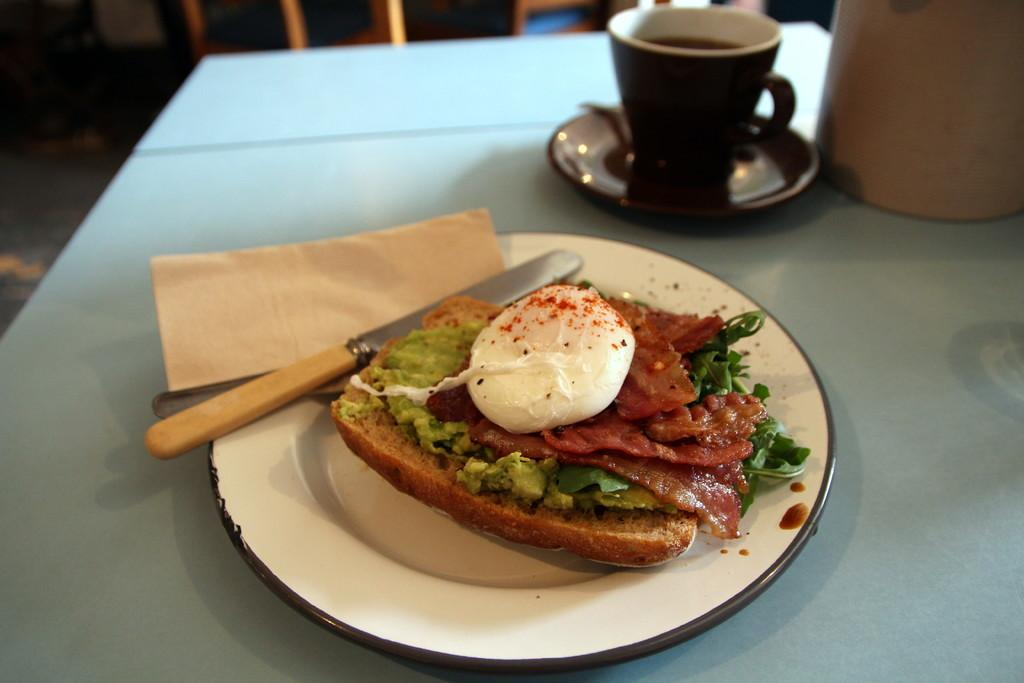What is located in the center of the image? There is a table in the center of the image. What is placed on the table? There is a plate, a knife, a napkin, a cup, and food on the table. Can you describe the utensils on the table? There is a knife on the table. What might be used for wiping or drying in the image? A napkin is present on the table for wiping or drying. What type of tin can be seen in the sky in the image? There is no tin or sky present in the image; it features a table with various items on it. Is there a door visible in the image? No, there is no door visible in the image; it only shows a table with various items on it. 